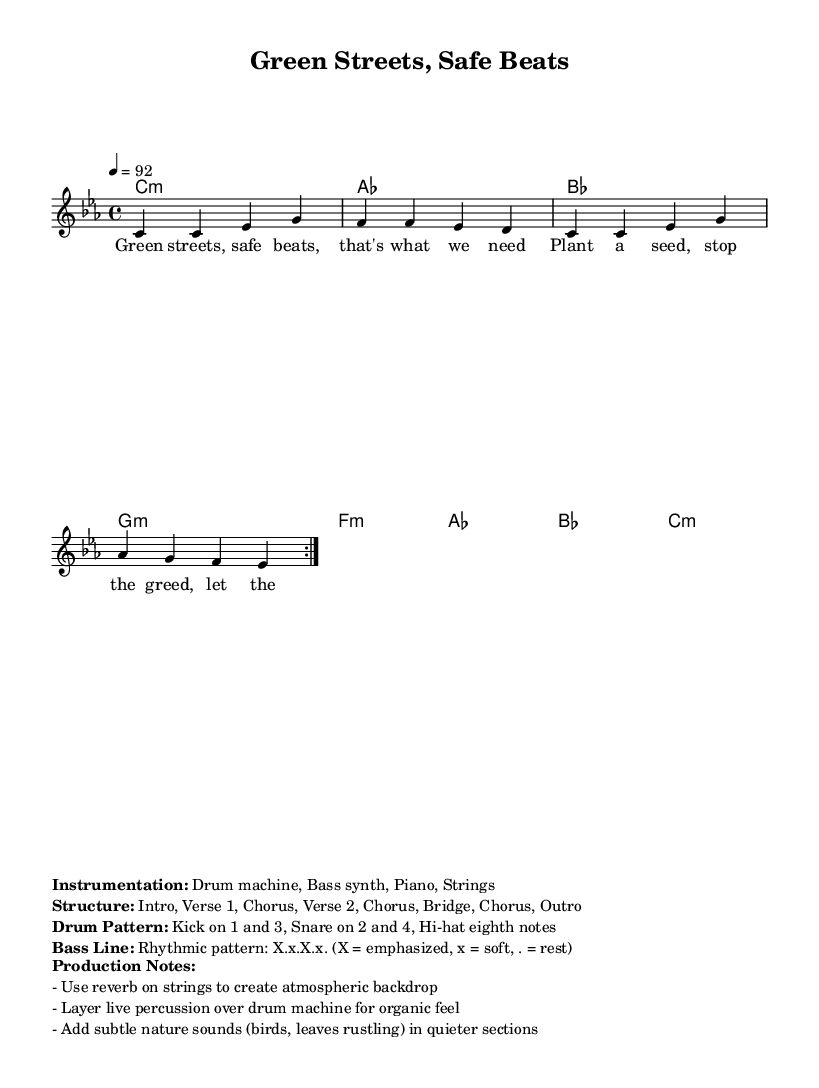What is the key signature of this music? The key signature is C minor, which includes three flats: B-flat, E-flat, and A-flat.
Answer: C minor What is the time signature of this music? The time signature is displayed in the score as 4/4, which means there are four beats in each measure and the quarter note gets one beat.
Answer: 4/4 What is the tempo marking of this piece? The tempo is indicated as 4 = 92, which means there are 92 beats per minute in quarter note beats.
Answer: 92 How many measures are in the melody section? The melody section has 8 measures in total, as indicated by the repeated volta section that plays twice (4 measures each time).
Answer: 8 measures What main theme does the lyrics suggest? The lyrics suggest themes of environmental consciousness and personal safety, as noted in phrases like "Plant a seed, stop the greed, let the earth breathe."
Answer: Environmental consciousness What instruments are mentioned in the instrumentation? The instrumentation includes Drum machine, Bass synth, Piano, and Strings, as listed in the markup.
Answer: Drum machine, Bass synth, Piano, Strings What unique aspect reflects the genre of Rap in this music? The music incorporates a rhythmic pattern in the bass line and a structured layout typical of rap, featuring verses and choruses focusing on social themes.
Answer: Rhythmic pattern and structured layout 